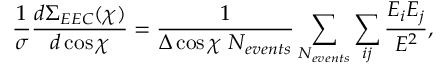<formula> <loc_0><loc_0><loc_500><loc_500>\frac { 1 } { \sigma } \frac { d \Sigma _ { E E C } ( \chi ) } { d \cos \chi } = \frac { 1 } { \Delta \cos \chi N _ { e v e n t s } } \sum _ { N _ { e v e n t s } } \sum _ { i j } \frac { E _ { i } E _ { j } } { E ^ { 2 } } ,</formula> 